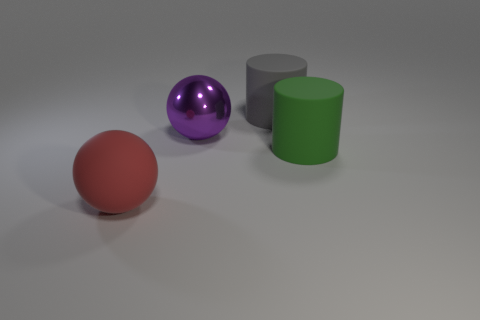Does the purple metal thing have the same shape as the red thing?
Your response must be concise. Yes. How many objects are large things in front of the big gray rubber cylinder or cyan things?
Offer a terse response. 3. What is the color of the big shiny thing?
Your answer should be compact. Purple. There is a purple sphere that is in front of the large gray rubber cylinder; what is its material?
Offer a very short reply. Metal. There is a large red matte thing; is it the same shape as the big thing behind the large purple metallic sphere?
Provide a succinct answer. No. Is the number of big gray rubber cylinders greater than the number of large blue shiny cylinders?
Your answer should be compact. Yes. Are there any other things of the same color as the large rubber ball?
Keep it short and to the point. No. What is the shape of the green thing that is made of the same material as the red sphere?
Your answer should be compact. Cylinder. What is the material of the sphere that is on the left side of the ball on the right side of the matte ball?
Ensure brevity in your answer.  Rubber. Is the shape of the matte object behind the big green matte thing the same as  the big green object?
Ensure brevity in your answer.  Yes. 